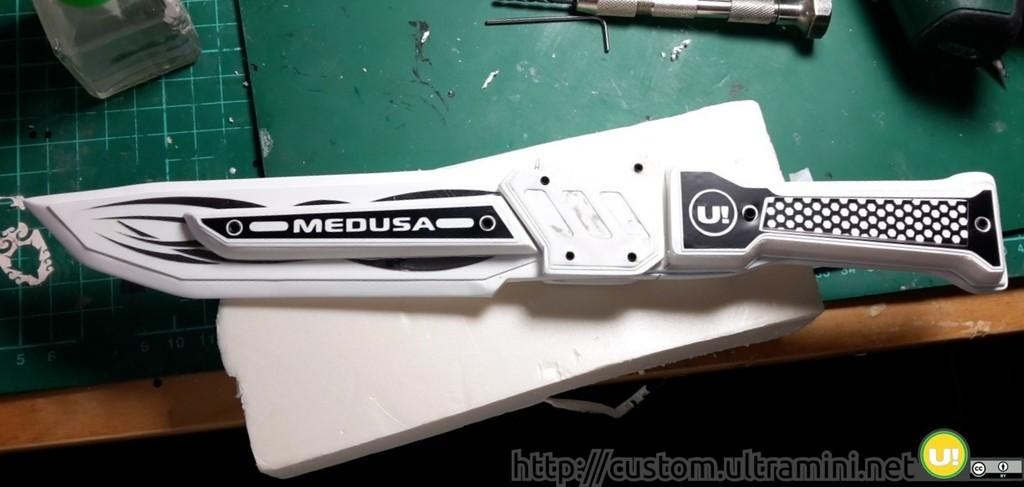What object can be seen in the image? There is a knife in the image. How many mice are seen eating the cheese in the image? There is no cheese or mice present in the image; only a knife is visible. 